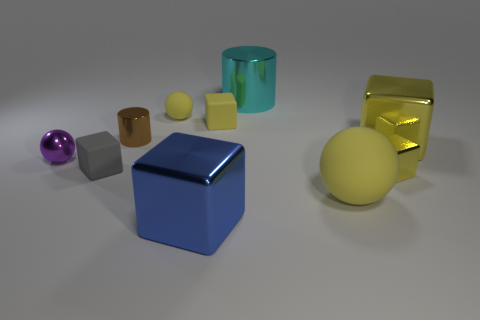What number of tiny matte blocks are to the left of the big blue thing?
Offer a terse response. 1. Are there fewer large cylinders that are behind the large metal cylinder than large yellow spheres?
Make the answer very short. Yes. The tiny matte ball is what color?
Offer a terse response. Yellow. There is a shiny cube that is on the left side of the large cylinder; is it the same color as the big ball?
Provide a succinct answer. No. There is another small rubber object that is the same shape as the small gray object; what is its color?
Keep it short and to the point. Yellow. What number of large things are either brown metallic objects or rubber cubes?
Your answer should be compact. 0. There is a yellow metallic thing that is behind the gray object; how big is it?
Offer a terse response. Large. Are there any tiny things that have the same color as the tiny shiny cylinder?
Keep it short and to the point. No. Is the color of the tiny metallic cylinder the same as the big cylinder?
Make the answer very short. No. There is a large shiny thing that is the same color as the large matte ball; what is its shape?
Your response must be concise. Cube. 